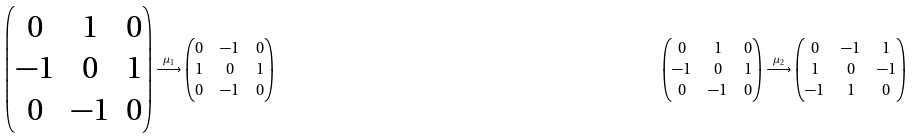Convert formula to latex. <formula><loc_0><loc_0><loc_500><loc_500>\begin{pmatrix} 0 & 1 & 0 \\ - 1 & 0 & 1 \\ 0 & - 1 & 0 \end{pmatrix} & \stackrel { \mu _ { 1 } } { \longrightarrow } \begin{pmatrix} 0 & - 1 & 0 \\ 1 & 0 & 1 \\ 0 & - 1 & 0 \end{pmatrix} & \begin{pmatrix} 0 & 1 & 0 \\ - 1 & 0 & 1 \\ 0 & - 1 & 0 \end{pmatrix} & \stackrel { \mu _ { 2 } } { \longrightarrow } \begin{pmatrix} 0 & - 1 & 1 \\ 1 & 0 & - 1 \\ - 1 & 1 & 0 \end{pmatrix}</formula> 